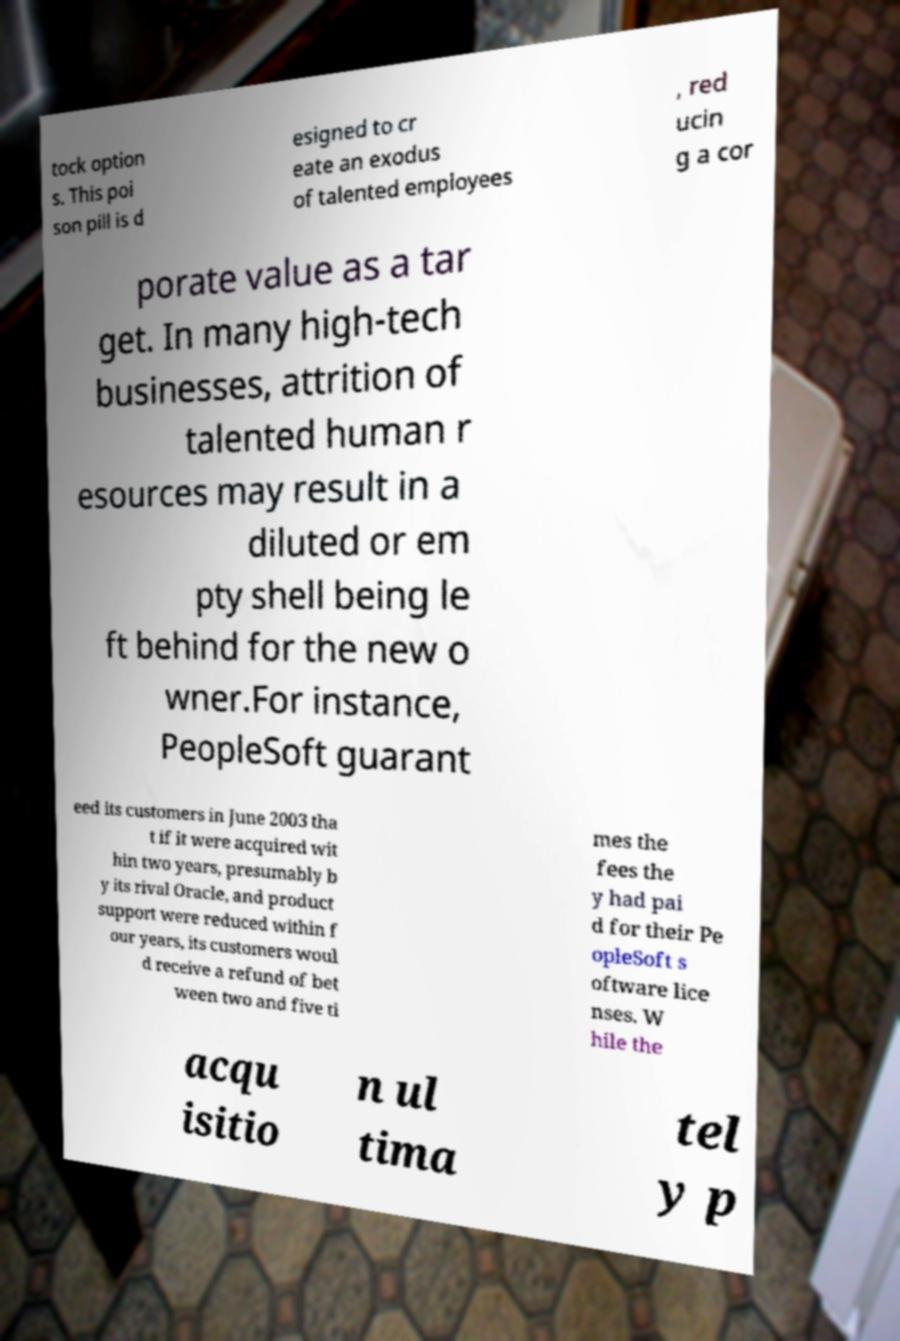Could you assist in decoding the text presented in this image and type it out clearly? tock option s. This poi son pill is d esigned to cr eate an exodus of talented employees , red ucin g a cor porate value as a tar get. In many high-tech businesses, attrition of talented human r esources may result in a diluted or em pty shell being le ft behind for the new o wner.For instance, PeopleSoft guarant eed its customers in June 2003 tha t if it were acquired wit hin two years, presumably b y its rival Oracle, and product support were reduced within f our years, its customers woul d receive a refund of bet ween two and five ti mes the fees the y had pai d for their Pe opleSoft s oftware lice nses. W hile the acqu isitio n ul tima tel y p 